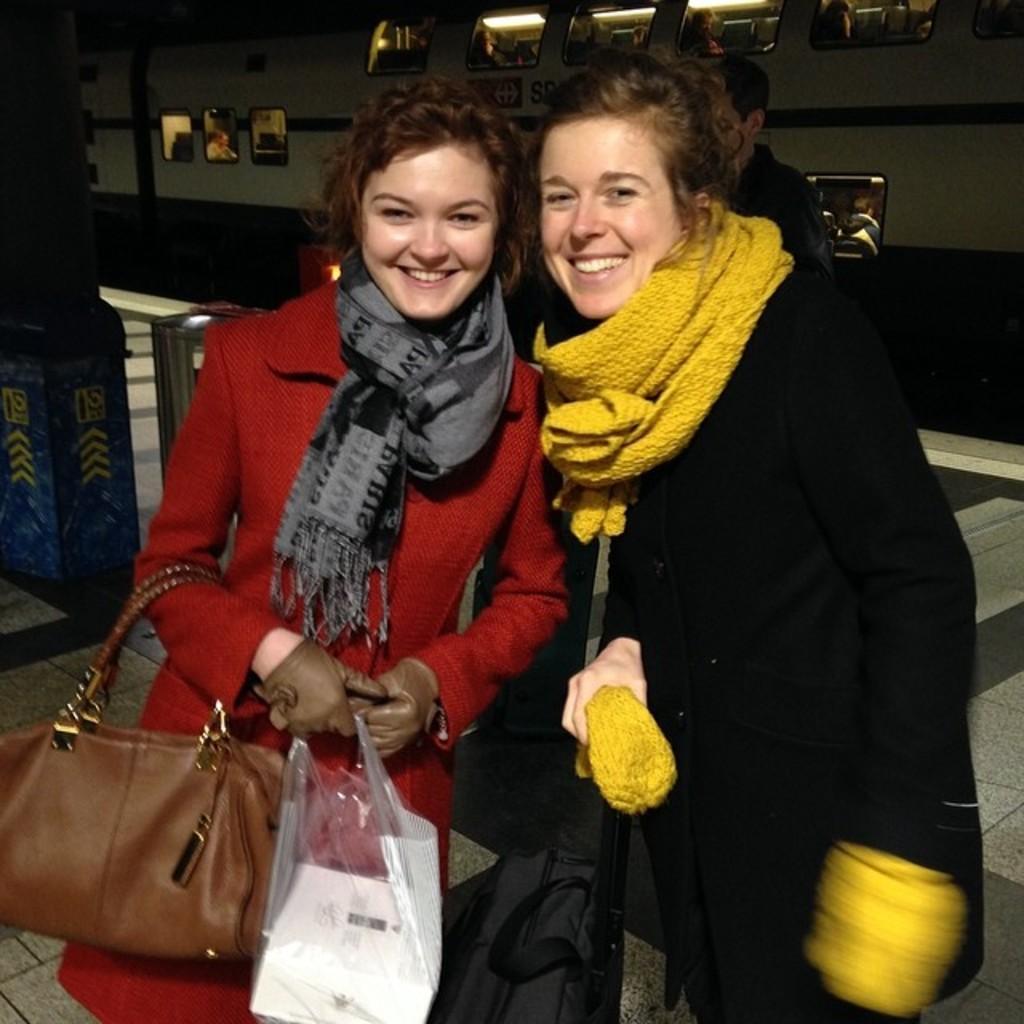Could you give a brief overview of what you see in this image? This is the picture taken in a station, there are two woman standing on the path. The woman in red coat holding a bag and a carry bag. The woman in black coat wearing a yellow color scarf. Background of this people is a vehicle. 